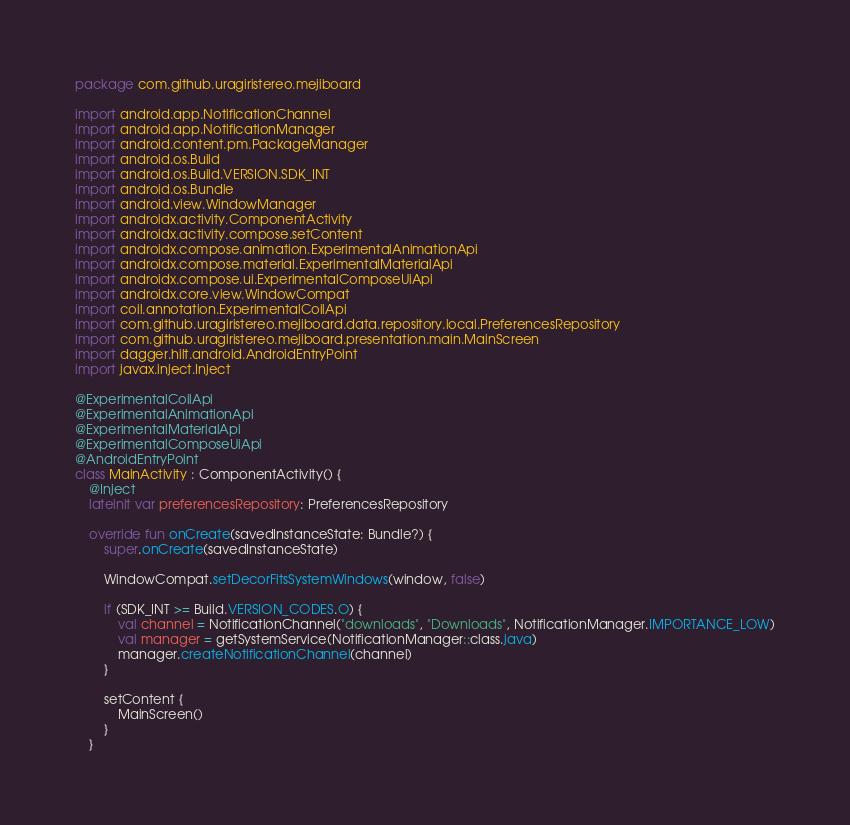Convert code to text. <code><loc_0><loc_0><loc_500><loc_500><_Kotlin_>package com.github.uragiristereo.mejiboard

import android.app.NotificationChannel
import android.app.NotificationManager
import android.content.pm.PackageManager
import android.os.Build
import android.os.Build.VERSION.SDK_INT
import android.os.Bundle
import android.view.WindowManager
import androidx.activity.ComponentActivity
import androidx.activity.compose.setContent
import androidx.compose.animation.ExperimentalAnimationApi
import androidx.compose.material.ExperimentalMaterialApi
import androidx.compose.ui.ExperimentalComposeUiApi
import androidx.core.view.WindowCompat
import coil.annotation.ExperimentalCoilApi
import com.github.uragiristereo.mejiboard.data.repository.local.PreferencesRepository
import com.github.uragiristereo.mejiboard.presentation.main.MainScreen
import dagger.hilt.android.AndroidEntryPoint
import javax.inject.Inject

@ExperimentalCoilApi
@ExperimentalAnimationApi
@ExperimentalMaterialApi
@ExperimentalComposeUiApi
@AndroidEntryPoint
class MainActivity : ComponentActivity() {
    @Inject
    lateinit var preferencesRepository: PreferencesRepository

    override fun onCreate(savedInstanceState: Bundle?) {
        super.onCreate(savedInstanceState)

        WindowCompat.setDecorFitsSystemWindows(window, false)

        if (SDK_INT >= Build.VERSION_CODES.O) {
            val channel = NotificationChannel("downloads", "Downloads", NotificationManager.IMPORTANCE_LOW)
            val manager = getSystemService(NotificationManager::class.java)
            manager.createNotificationChannel(channel)
        }

        setContent {
            MainScreen()
        }
    }
</code> 